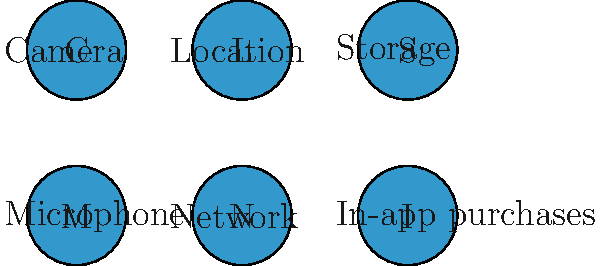Based on the given icons representing Android app permissions, which combination of permissions would be required for an app that needs to save photos taken by the user and access their current location? To determine the correct combination of permissions, let's analyze the requirements and match them with the given icons:

1. The app needs to save photos taken by the user:
   - This requires access to the device's camera to take photos.
   - It also requires access to storage to save the photos.

2. The app needs to access the user's current location:
   - This requires access to the device's location services.

Now, let's identify the corresponding icons:

1. Camera: Represented by the icon labeled "C"
2. Storage: Represented by the icon labeled "S"
3. Location: Represented by the icon labeled "L"

Therefore, the combination of permissions required for this app would be Camera (C), Storage (S), and Location (L).
Answer: C, S, L 